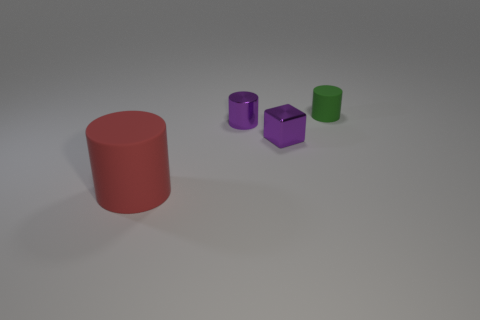Subtract all matte cylinders. How many cylinders are left? 1 Add 4 tiny yellow matte cylinders. How many objects exist? 8 Subtract all cylinders. How many objects are left? 1 Subtract 0 cyan blocks. How many objects are left? 4 Subtract all red matte objects. Subtract all small purple blocks. How many objects are left? 2 Add 4 big matte things. How many big matte things are left? 5 Add 3 red cylinders. How many red cylinders exist? 4 